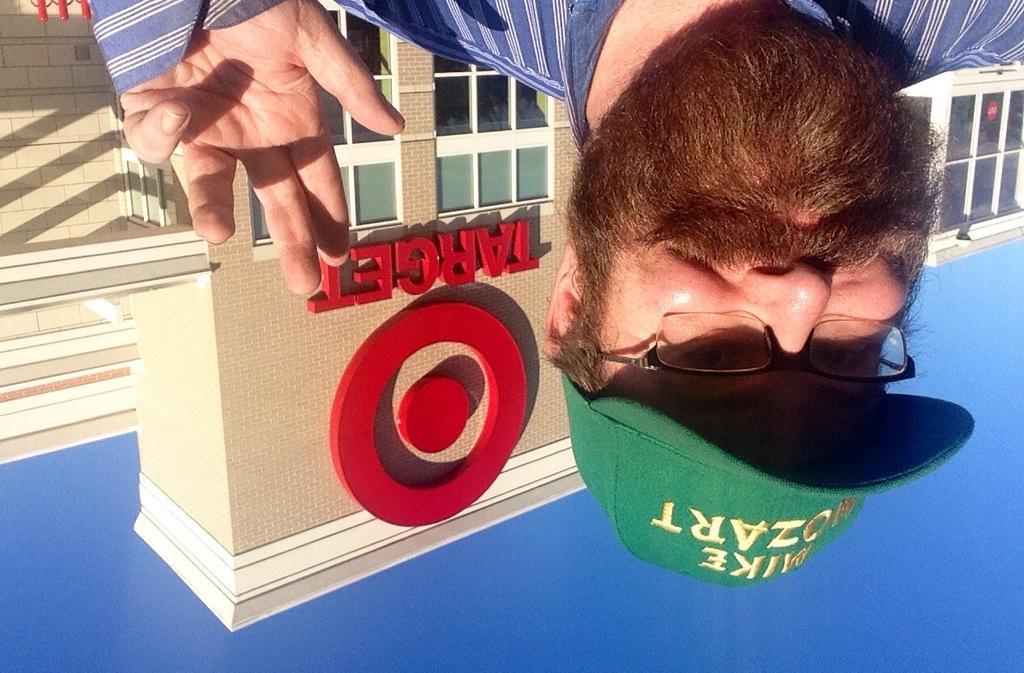Describe this image in one or two sentences. In this picture, we see the man in the blue shirt is wearing the spectacles. He is even wearing a green cap. Behind him, we see a building. We see windows and "TARGET" written on the building. At the bottom, we see the sky, which is blue in color. 